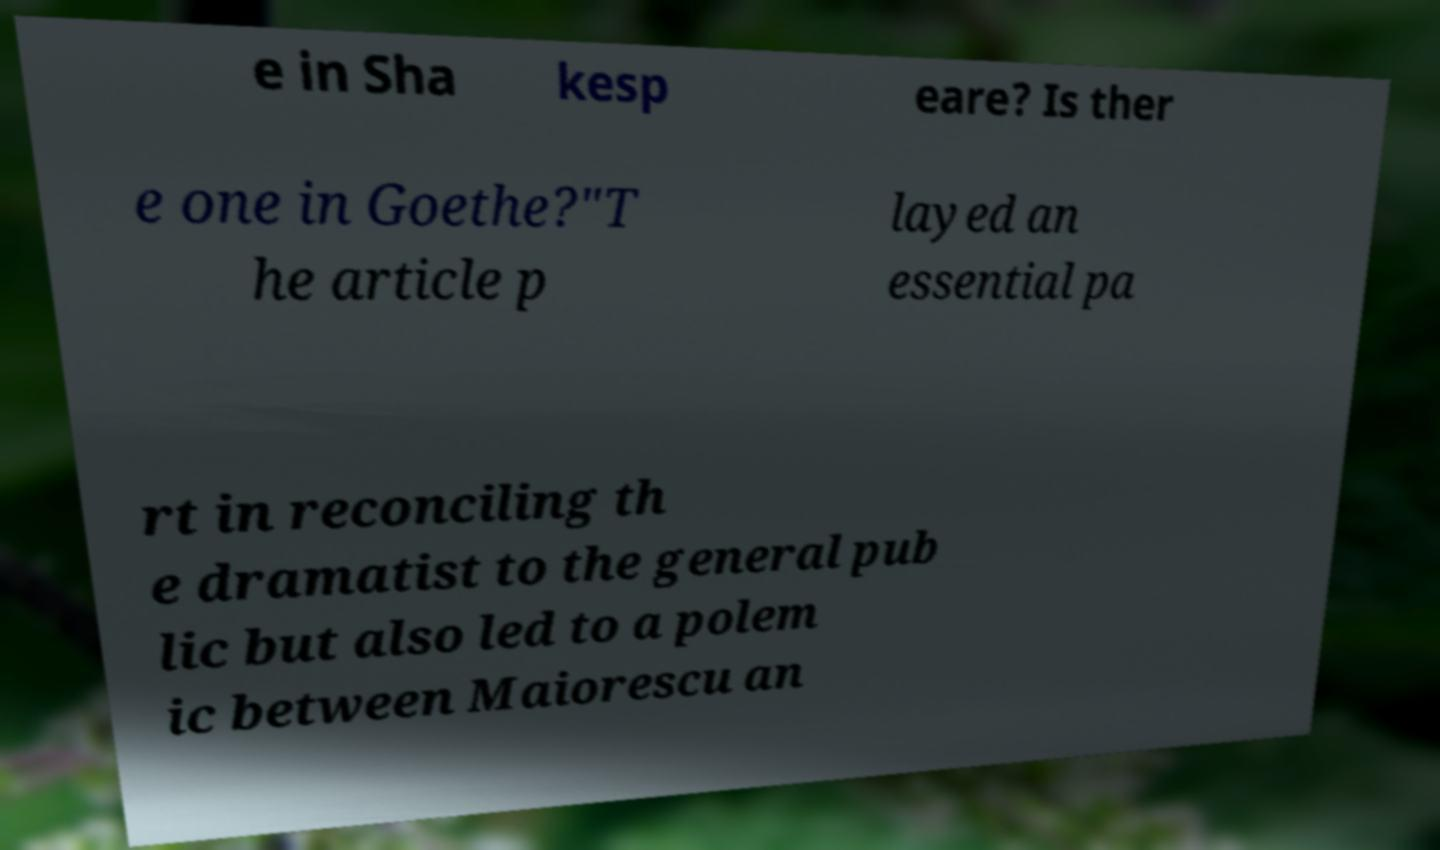Could you extract and type out the text from this image? e in Sha kesp eare? Is ther e one in Goethe?"T he article p layed an essential pa rt in reconciling th e dramatist to the general pub lic but also led to a polem ic between Maiorescu an 